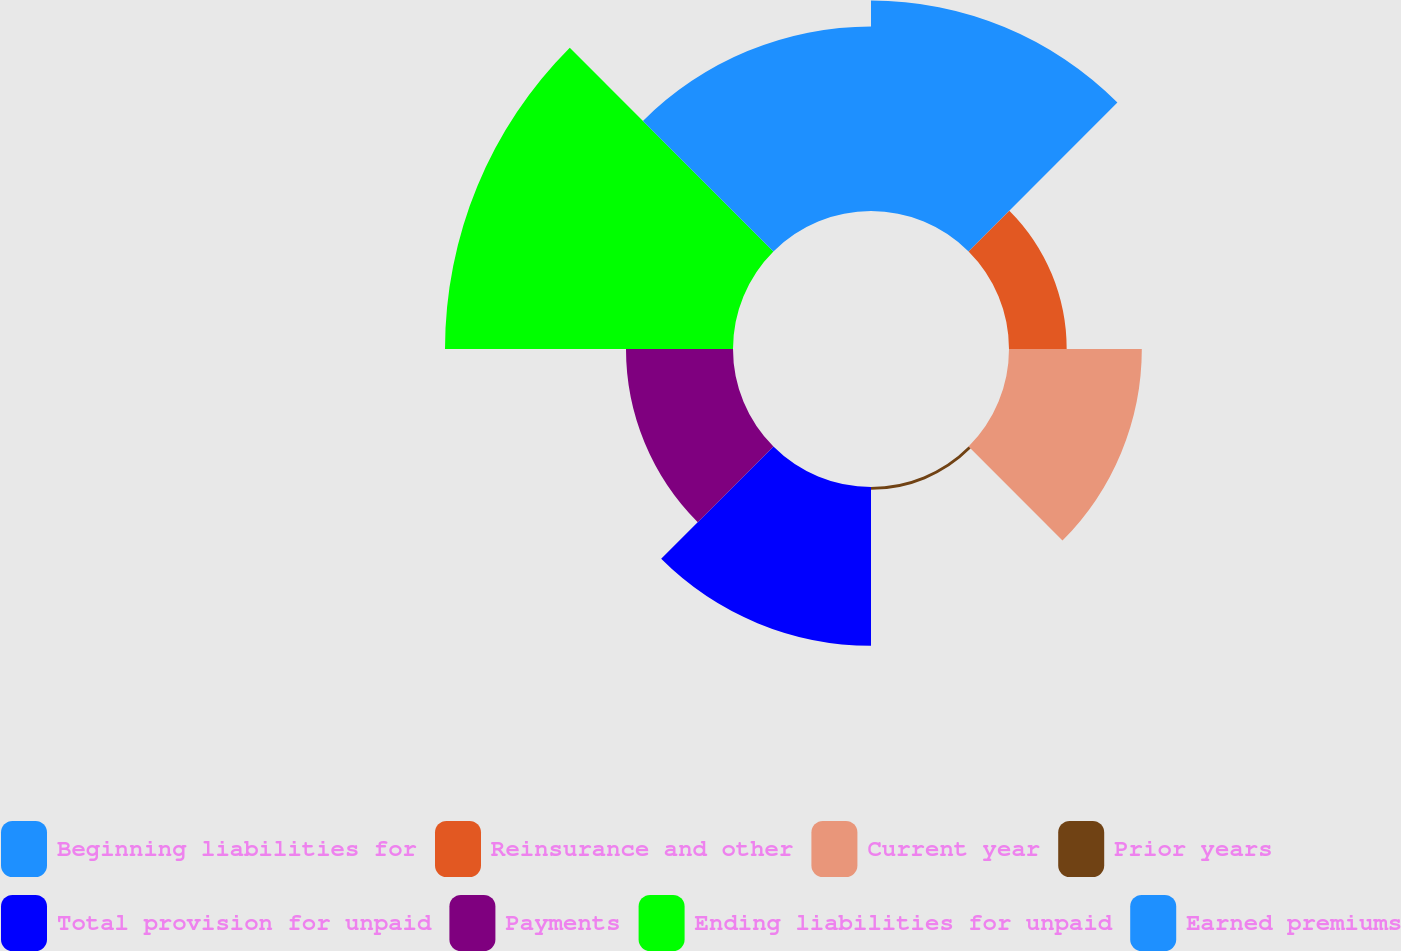Convert chart to OTSL. <chart><loc_0><loc_0><loc_500><loc_500><pie_chart><fcel>Beginning liabilities for<fcel>Reinsurance and other<fcel>Current year<fcel>Prior years<fcel>Total provision for unpaid<fcel>Payments<fcel>Ending liabilities for unpaid<fcel>Earned premiums<nl><fcel>18.43%<fcel>5.05%<fcel>11.63%<fcel>0.25%<fcel>13.9%<fcel>9.37%<fcel>25.22%<fcel>16.16%<nl></chart> 